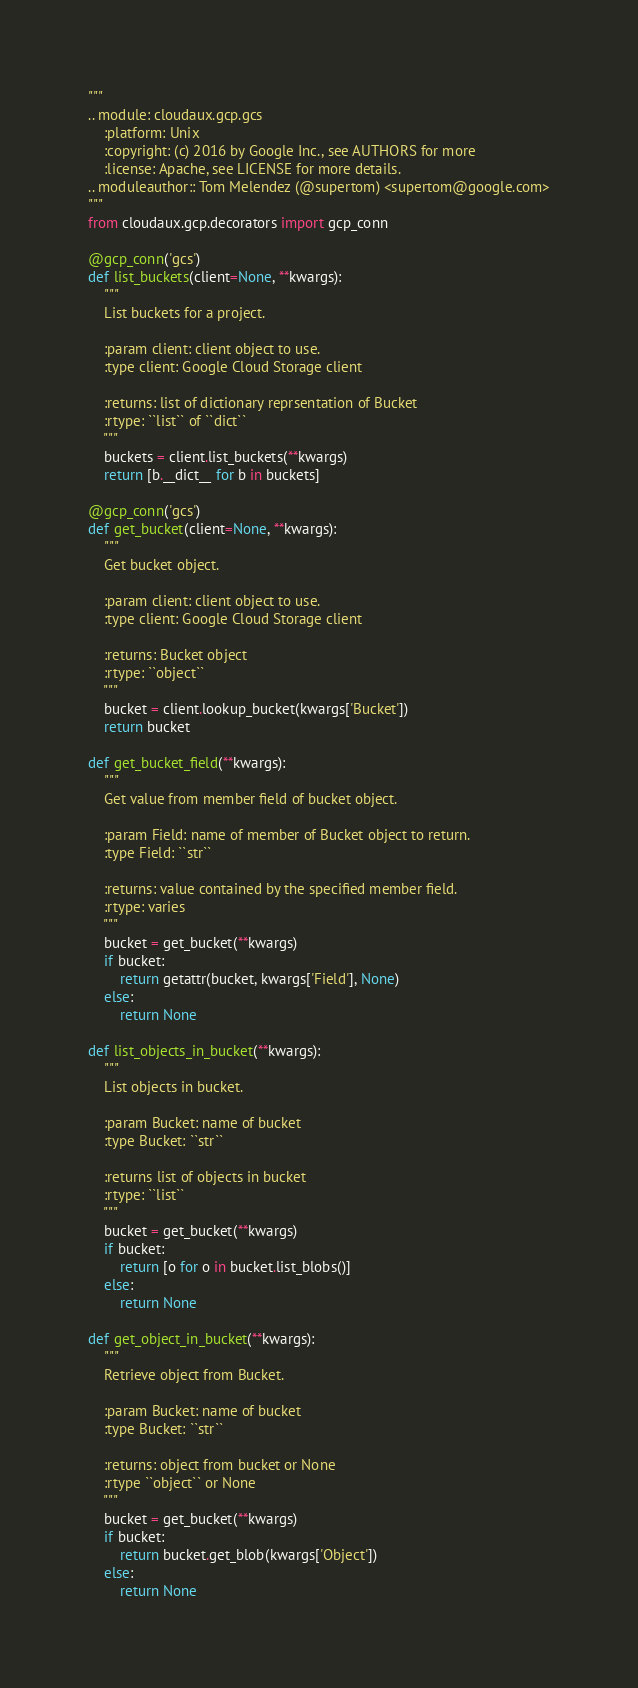Convert code to text. <code><loc_0><loc_0><loc_500><loc_500><_Python_>"""
.. module: cloudaux.gcp.gcs
    :platform: Unix
    :copyright: (c) 2016 by Google Inc., see AUTHORS for more
    :license: Apache, see LICENSE for more details.
.. moduleauthor:: Tom Melendez (@supertom) <supertom@google.com>
"""
from cloudaux.gcp.decorators import gcp_conn

@gcp_conn('gcs')
def list_buckets(client=None, **kwargs):
    """
    List buckets for a project.

    :param client: client object to use.
    :type client: Google Cloud Storage client

    :returns: list of dictionary reprsentation of Bucket
    :rtype: ``list`` of ``dict``
    """
    buckets = client.list_buckets(**kwargs)
    return [b.__dict__ for b in buckets]

@gcp_conn('gcs')
def get_bucket(client=None, **kwargs):
    """
    Get bucket object.

    :param client: client object to use.
    :type client: Google Cloud Storage client

    :returns: Bucket object
    :rtype: ``object``
    """
    bucket = client.lookup_bucket(kwargs['Bucket'])
    return bucket
    
def get_bucket_field(**kwargs):
    """
    Get value from member field of bucket object.

    :param Field: name of member of Bucket object to return.
    :type Field: ``str``

    :returns: value contained by the specified member field.
    :rtype: varies
    """
    bucket = get_bucket(**kwargs)
    if bucket:
        return getattr(bucket, kwargs['Field'], None)
    else:
        return None

def list_objects_in_bucket(**kwargs):
    """
    List objects in bucket.

    :param Bucket: name of bucket
    :type Bucket: ``str``

    :returns list of objects in bucket
    :rtype: ``list``
    """
    bucket = get_bucket(**kwargs)
    if bucket:
        return [o for o in bucket.list_blobs()]
    else:
        return None

def get_object_in_bucket(**kwargs):
    """
    Retrieve object from Bucket.

    :param Bucket: name of bucket
    :type Bucket: ``str``

    :returns: object from bucket or None
    :rtype ``object`` or None
    """
    bucket = get_bucket(**kwargs)
    if bucket:
        return bucket.get_blob(kwargs['Object'])
    else:
        return None
</code> 